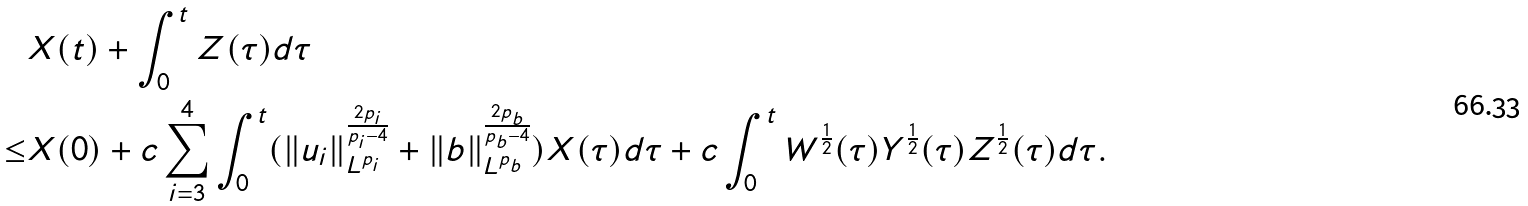Convert formula to latex. <formula><loc_0><loc_0><loc_500><loc_500>& X ( t ) + \int _ { 0 } ^ { t } Z ( \tau ) d \tau \\ \leq & X ( 0 ) + c \sum _ { i = 3 } ^ { 4 } \int _ { 0 } ^ { t } ( \| u _ { i } \| _ { L ^ { p _ { i } } } ^ { \frac { 2 p _ { i } } { p _ { i } - 4 } } + \| b \| _ { L ^ { p _ { b } } } ^ { \frac { 2 p _ { b } } { p _ { b } - 4 } } ) X ( \tau ) d \tau + c \int _ { 0 } ^ { t } W ^ { \frac { 1 } { 2 } } ( \tau ) Y ^ { \frac { 1 } { 2 } } ( \tau ) Z ^ { \frac { 1 } { 2 } } ( \tau ) d \tau .</formula> 